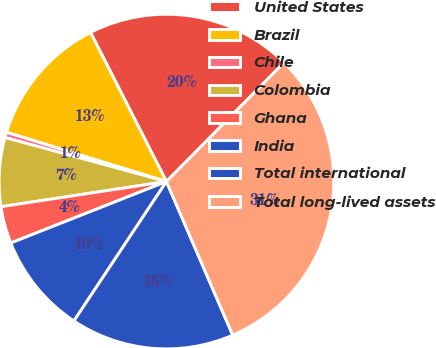Convert chart. <chart><loc_0><loc_0><loc_500><loc_500><pie_chart><fcel>United States<fcel>Brazil<fcel>Chile<fcel>Colombia<fcel>Ghana<fcel>India<fcel>Total international<fcel>Total long-lived assets<nl><fcel>19.9%<fcel>12.75%<fcel>0.52%<fcel>6.64%<fcel>3.58%<fcel>9.69%<fcel>15.81%<fcel>31.11%<nl></chart> 